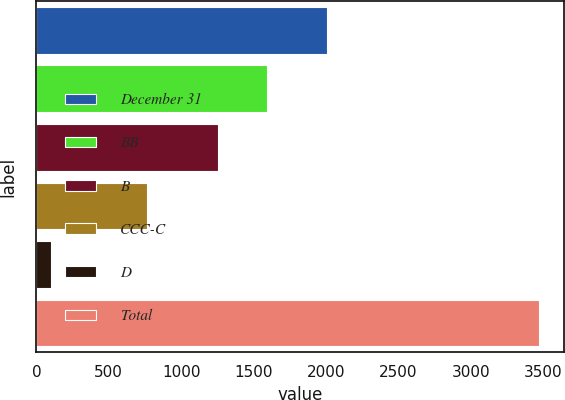Convert chart to OTSL. <chart><loc_0><loc_0><loc_500><loc_500><bar_chart><fcel>December 31<fcel>BB<fcel>B<fcel>CCC-C<fcel>D<fcel>Total<nl><fcel>2009<fcel>1591.8<fcel>1255<fcel>761<fcel>98<fcel>3466<nl></chart> 